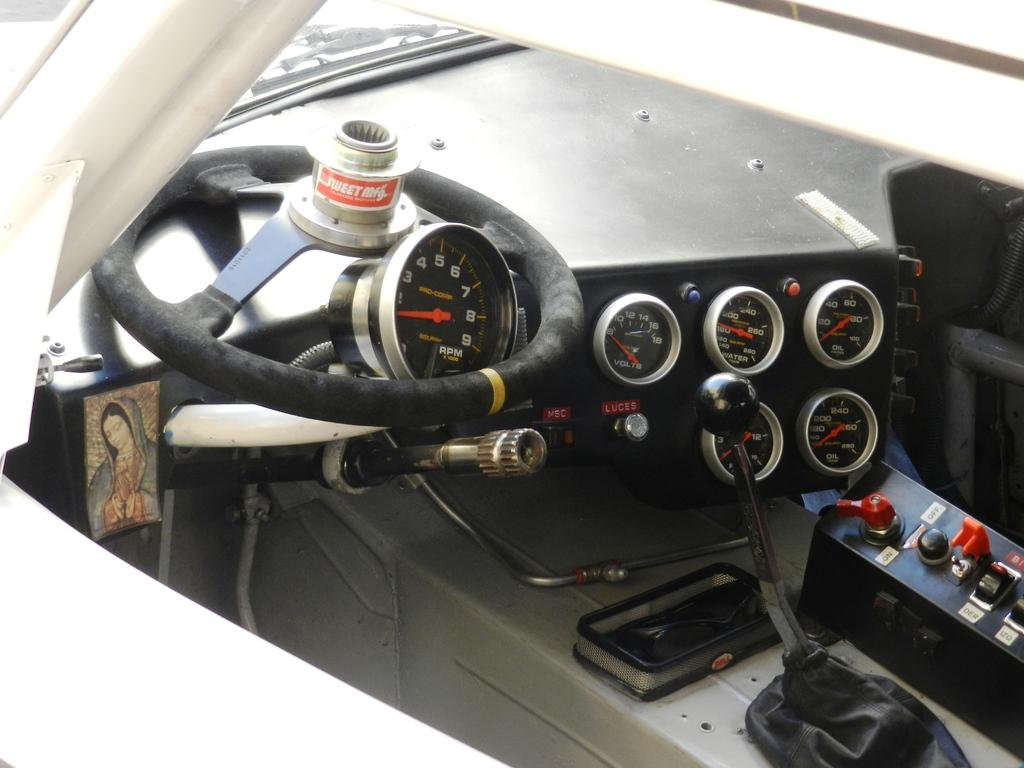What is the condition of the steering in the image? The steering in the image is broken. What other mechanical component can be seen in the image? There is a gear rod in the image. What type of instrument is present in the image? There are analog meters in the image. What is the setting of the image? The image is taken inside a vehicle. What color is the slope in the image? There is no slope present in the image. How does the vehicle defend itself against the attack in the image? There is no attack present in the image. 